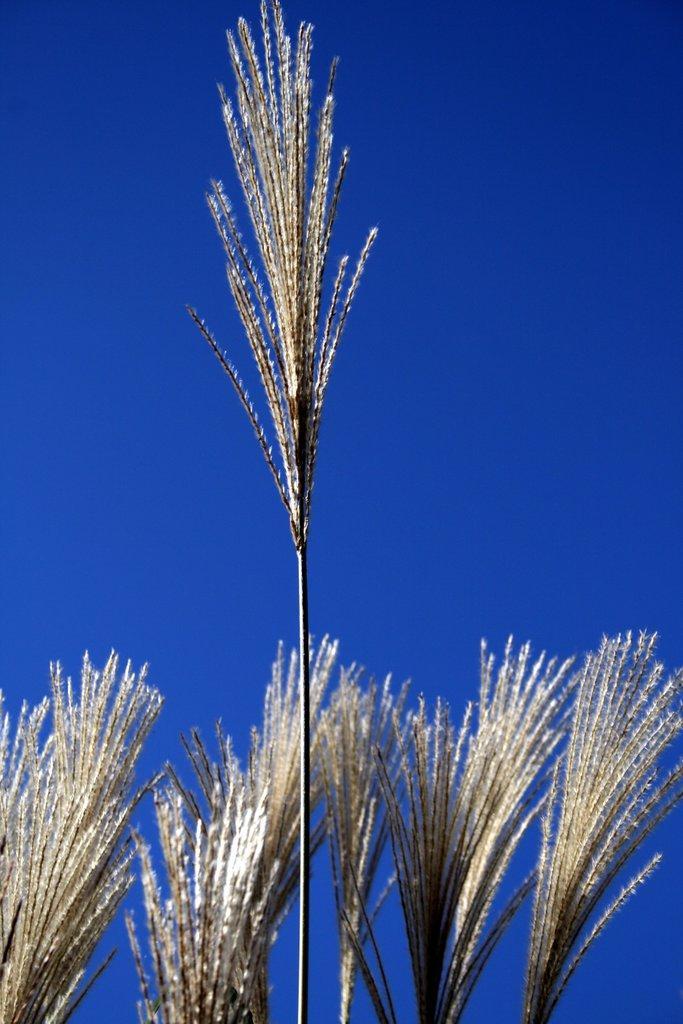Please provide a concise description of this image. In this image there are plants. Behind them there is the sky. 